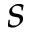Convert formula to latex. <formula><loc_0><loc_0><loc_500><loc_500>s</formula> 